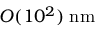Convert formula to latex. <formula><loc_0><loc_0><loc_500><loc_500>O ( 1 0 ^ { 2 } ) \, n m</formula> 